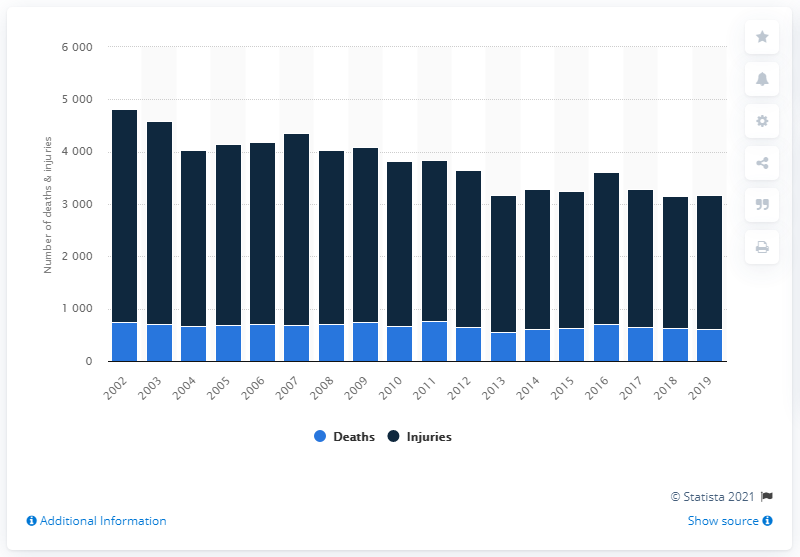Draw attention to some important aspects in this diagram. In 2019, a total of 613 people lost their lives due to boating accidents in the United States. 